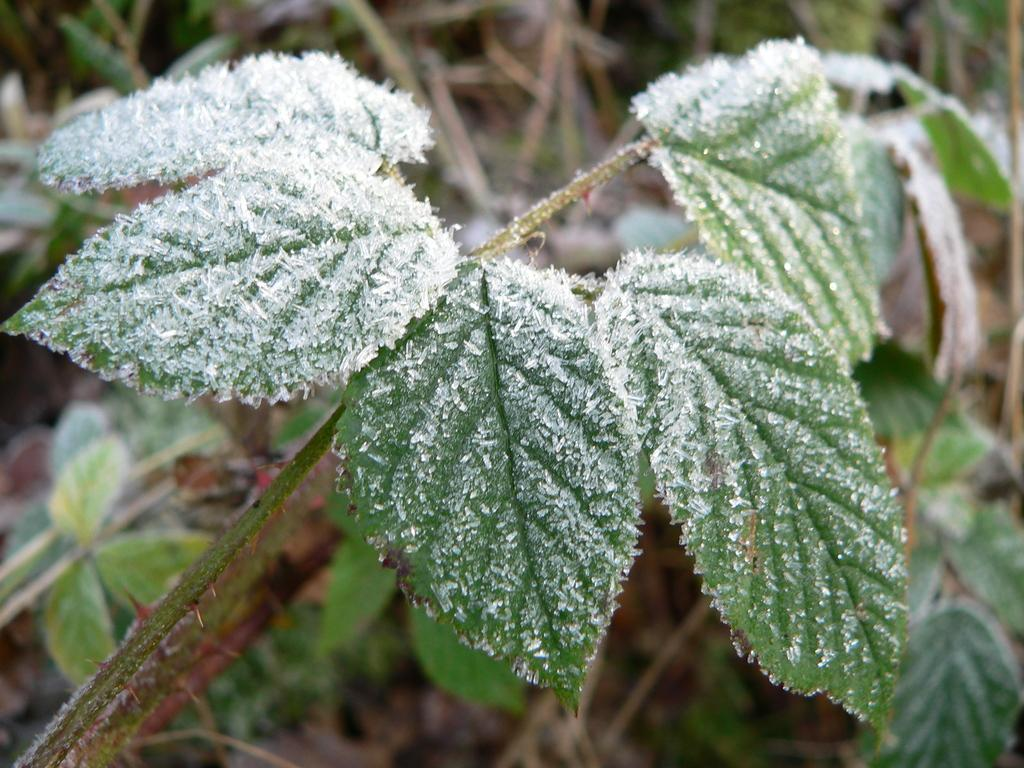What is present in the image? There is a plant in the image. What can be observed about the plant's appearance? The plant has leaves. What is the condition of the plant in the image? There is frost on the plant. What type of tray is used to hold the balloon in the image? There is no tray or balloon present in the image; it only features a plant with frost on it. 